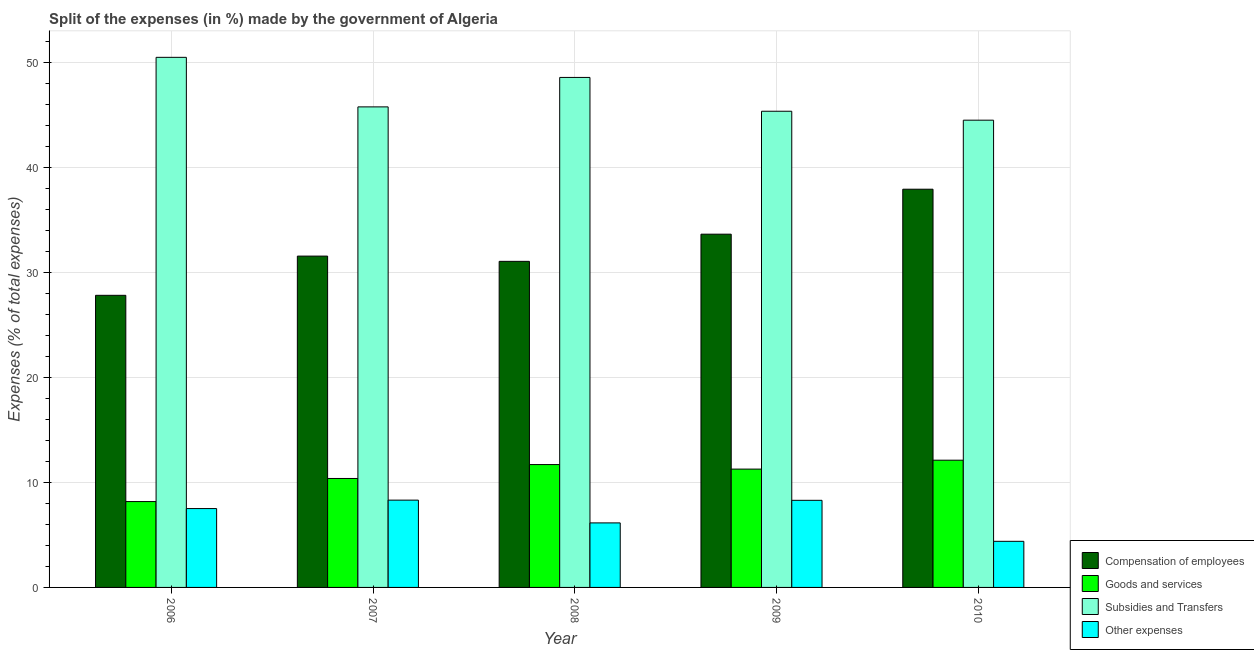How many different coloured bars are there?
Offer a terse response. 4. Are the number of bars per tick equal to the number of legend labels?
Your answer should be very brief. Yes. Are the number of bars on each tick of the X-axis equal?
Offer a terse response. Yes. How many bars are there on the 5th tick from the left?
Offer a terse response. 4. What is the percentage of amount spent on subsidies in 2009?
Offer a terse response. 45.37. Across all years, what is the maximum percentage of amount spent on goods and services?
Provide a succinct answer. 12.12. Across all years, what is the minimum percentage of amount spent on goods and services?
Make the answer very short. 8.18. In which year was the percentage of amount spent on subsidies maximum?
Provide a short and direct response. 2006. What is the total percentage of amount spent on compensation of employees in the graph?
Your response must be concise. 162.06. What is the difference between the percentage of amount spent on other expenses in 2009 and that in 2010?
Make the answer very short. 3.91. What is the difference between the percentage of amount spent on goods and services in 2008 and the percentage of amount spent on subsidies in 2007?
Provide a short and direct response. 1.32. What is the average percentage of amount spent on compensation of employees per year?
Provide a short and direct response. 32.41. In the year 2009, what is the difference between the percentage of amount spent on goods and services and percentage of amount spent on other expenses?
Offer a terse response. 0. In how many years, is the percentage of amount spent on compensation of employees greater than 22 %?
Give a very brief answer. 5. What is the ratio of the percentage of amount spent on subsidies in 2007 to that in 2009?
Give a very brief answer. 1.01. Is the percentage of amount spent on goods and services in 2009 less than that in 2010?
Provide a short and direct response. Yes. Is the difference between the percentage of amount spent on compensation of employees in 2009 and 2010 greater than the difference between the percentage of amount spent on other expenses in 2009 and 2010?
Offer a terse response. No. What is the difference between the highest and the second highest percentage of amount spent on subsidies?
Keep it short and to the point. 1.91. What is the difference between the highest and the lowest percentage of amount spent on goods and services?
Your answer should be compact. 3.94. What does the 2nd bar from the left in 2010 represents?
Your answer should be very brief. Goods and services. What does the 3rd bar from the right in 2006 represents?
Your response must be concise. Goods and services. Is it the case that in every year, the sum of the percentage of amount spent on compensation of employees and percentage of amount spent on goods and services is greater than the percentage of amount spent on subsidies?
Offer a very short reply. No. Are all the bars in the graph horizontal?
Provide a short and direct response. No. How many years are there in the graph?
Provide a succinct answer. 5. Does the graph contain grids?
Keep it short and to the point. Yes. How many legend labels are there?
Ensure brevity in your answer.  4. What is the title of the graph?
Make the answer very short. Split of the expenses (in %) made by the government of Algeria. What is the label or title of the X-axis?
Make the answer very short. Year. What is the label or title of the Y-axis?
Keep it short and to the point. Expenses (% of total expenses). What is the Expenses (% of total expenses) in Compensation of employees in 2006?
Offer a very short reply. 27.83. What is the Expenses (% of total expenses) of Goods and services in 2006?
Provide a short and direct response. 8.18. What is the Expenses (% of total expenses) of Subsidies and Transfers in 2006?
Provide a succinct answer. 50.5. What is the Expenses (% of total expenses) of Other expenses in 2006?
Offer a very short reply. 7.51. What is the Expenses (% of total expenses) in Compensation of employees in 2007?
Provide a short and direct response. 31.57. What is the Expenses (% of total expenses) in Goods and services in 2007?
Ensure brevity in your answer.  10.38. What is the Expenses (% of total expenses) in Subsidies and Transfers in 2007?
Ensure brevity in your answer.  45.78. What is the Expenses (% of total expenses) of Other expenses in 2007?
Offer a terse response. 8.32. What is the Expenses (% of total expenses) in Compensation of employees in 2008?
Your response must be concise. 31.07. What is the Expenses (% of total expenses) of Goods and services in 2008?
Offer a very short reply. 11.7. What is the Expenses (% of total expenses) in Subsidies and Transfers in 2008?
Your response must be concise. 48.59. What is the Expenses (% of total expenses) of Other expenses in 2008?
Offer a terse response. 6.15. What is the Expenses (% of total expenses) in Compensation of employees in 2009?
Provide a succinct answer. 33.66. What is the Expenses (% of total expenses) of Goods and services in 2009?
Make the answer very short. 11.27. What is the Expenses (% of total expenses) of Subsidies and Transfers in 2009?
Provide a short and direct response. 45.37. What is the Expenses (% of total expenses) of Other expenses in 2009?
Keep it short and to the point. 8.3. What is the Expenses (% of total expenses) of Compensation of employees in 2010?
Offer a very short reply. 37.94. What is the Expenses (% of total expenses) in Goods and services in 2010?
Make the answer very short. 12.12. What is the Expenses (% of total expenses) of Subsidies and Transfers in 2010?
Make the answer very short. 44.52. What is the Expenses (% of total expenses) of Other expenses in 2010?
Your answer should be very brief. 4.39. Across all years, what is the maximum Expenses (% of total expenses) of Compensation of employees?
Make the answer very short. 37.94. Across all years, what is the maximum Expenses (% of total expenses) of Goods and services?
Provide a short and direct response. 12.12. Across all years, what is the maximum Expenses (% of total expenses) in Subsidies and Transfers?
Offer a terse response. 50.5. Across all years, what is the maximum Expenses (% of total expenses) in Other expenses?
Ensure brevity in your answer.  8.32. Across all years, what is the minimum Expenses (% of total expenses) of Compensation of employees?
Ensure brevity in your answer.  27.83. Across all years, what is the minimum Expenses (% of total expenses) in Goods and services?
Ensure brevity in your answer.  8.18. Across all years, what is the minimum Expenses (% of total expenses) of Subsidies and Transfers?
Make the answer very short. 44.52. Across all years, what is the minimum Expenses (% of total expenses) of Other expenses?
Offer a terse response. 4.39. What is the total Expenses (% of total expenses) of Compensation of employees in the graph?
Give a very brief answer. 162.06. What is the total Expenses (% of total expenses) of Goods and services in the graph?
Your answer should be very brief. 53.66. What is the total Expenses (% of total expenses) of Subsidies and Transfers in the graph?
Ensure brevity in your answer.  234.76. What is the total Expenses (% of total expenses) of Other expenses in the graph?
Your response must be concise. 34.67. What is the difference between the Expenses (% of total expenses) of Compensation of employees in 2006 and that in 2007?
Provide a succinct answer. -3.74. What is the difference between the Expenses (% of total expenses) of Goods and services in 2006 and that in 2007?
Keep it short and to the point. -2.2. What is the difference between the Expenses (% of total expenses) in Subsidies and Transfers in 2006 and that in 2007?
Make the answer very short. 4.72. What is the difference between the Expenses (% of total expenses) of Other expenses in 2006 and that in 2007?
Your answer should be very brief. -0.8. What is the difference between the Expenses (% of total expenses) of Compensation of employees in 2006 and that in 2008?
Make the answer very short. -3.24. What is the difference between the Expenses (% of total expenses) of Goods and services in 2006 and that in 2008?
Your response must be concise. -3.52. What is the difference between the Expenses (% of total expenses) of Subsidies and Transfers in 2006 and that in 2008?
Your answer should be very brief. 1.91. What is the difference between the Expenses (% of total expenses) in Other expenses in 2006 and that in 2008?
Make the answer very short. 1.36. What is the difference between the Expenses (% of total expenses) in Compensation of employees in 2006 and that in 2009?
Keep it short and to the point. -5.83. What is the difference between the Expenses (% of total expenses) in Goods and services in 2006 and that in 2009?
Offer a very short reply. -3.09. What is the difference between the Expenses (% of total expenses) in Subsidies and Transfers in 2006 and that in 2009?
Offer a very short reply. 5.14. What is the difference between the Expenses (% of total expenses) of Other expenses in 2006 and that in 2009?
Your answer should be very brief. -0.79. What is the difference between the Expenses (% of total expenses) in Compensation of employees in 2006 and that in 2010?
Give a very brief answer. -10.11. What is the difference between the Expenses (% of total expenses) of Goods and services in 2006 and that in 2010?
Your answer should be very brief. -3.94. What is the difference between the Expenses (% of total expenses) of Subsidies and Transfers in 2006 and that in 2010?
Your answer should be compact. 5.99. What is the difference between the Expenses (% of total expenses) of Other expenses in 2006 and that in 2010?
Provide a short and direct response. 3.12. What is the difference between the Expenses (% of total expenses) of Compensation of employees in 2007 and that in 2008?
Give a very brief answer. 0.5. What is the difference between the Expenses (% of total expenses) in Goods and services in 2007 and that in 2008?
Provide a succinct answer. -1.32. What is the difference between the Expenses (% of total expenses) in Subsidies and Transfers in 2007 and that in 2008?
Your response must be concise. -2.81. What is the difference between the Expenses (% of total expenses) in Other expenses in 2007 and that in 2008?
Give a very brief answer. 2.17. What is the difference between the Expenses (% of total expenses) in Compensation of employees in 2007 and that in 2009?
Provide a short and direct response. -2.09. What is the difference between the Expenses (% of total expenses) in Goods and services in 2007 and that in 2009?
Provide a short and direct response. -0.89. What is the difference between the Expenses (% of total expenses) in Subsidies and Transfers in 2007 and that in 2009?
Make the answer very short. 0.42. What is the difference between the Expenses (% of total expenses) of Other expenses in 2007 and that in 2009?
Keep it short and to the point. 0.02. What is the difference between the Expenses (% of total expenses) of Compensation of employees in 2007 and that in 2010?
Ensure brevity in your answer.  -6.37. What is the difference between the Expenses (% of total expenses) of Goods and services in 2007 and that in 2010?
Provide a short and direct response. -1.74. What is the difference between the Expenses (% of total expenses) of Subsidies and Transfers in 2007 and that in 2010?
Provide a short and direct response. 1.27. What is the difference between the Expenses (% of total expenses) in Other expenses in 2007 and that in 2010?
Your response must be concise. 3.92. What is the difference between the Expenses (% of total expenses) of Compensation of employees in 2008 and that in 2009?
Your answer should be very brief. -2.59. What is the difference between the Expenses (% of total expenses) of Goods and services in 2008 and that in 2009?
Provide a succinct answer. 0.43. What is the difference between the Expenses (% of total expenses) in Subsidies and Transfers in 2008 and that in 2009?
Your answer should be compact. 3.22. What is the difference between the Expenses (% of total expenses) in Other expenses in 2008 and that in 2009?
Offer a very short reply. -2.15. What is the difference between the Expenses (% of total expenses) in Compensation of employees in 2008 and that in 2010?
Offer a terse response. -6.87. What is the difference between the Expenses (% of total expenses) in Goods and services in 2008 and that in 2010?
Give a very brief answer. -0.42. What is the difference between the Expenses (% of total expenses) in Subsidies and Transfers in 2008 and that in 2010?
Keep it short and to the point. 4.07. What is the difference between the Expenses (% of total expenses) of Other expenses in 2008 and that in 2010?
Provide a short and direct response. 1.75. What is the difference between the Expenses (% of total expenses) of Compensation of employees in 2009 and that in 2010?
Give a very brief answer. -4.28. What is the difference between the Expenses (% of total expenses) in Goods and services in 2009 and that in 2010?
Keep it short and to the point. -0.85. What is the difference between the Expenses (% of total expenses) in Subsidies and Transfers in 2009 and that in 2010?
Offer a terse response. 0.85. What is the difference between the Expenses (% of total expenses) of Other expenses in 2009 and that in 2010?
Make the answer very short. 3.91. What is the difference between the Expenses (% of total expenses) of Compensation of employees in 2006 and the Expenses (% of total expenses) of Goods and services in 2007?
Your response must be concise. 17.45. What is the difference between the Expenses (% of total expenses) in Compensation of employees in 2006 and the Expenses (% of total expenses) in Subsidies and Transfers in 2007?
Your answer should be very brief. -17.95. What is the difference between the Expenses (% of total expenses) of Compensation of employees in 2006 and the Expenses (% of total expenses) of Other expenses in 2007?
Provide a succinct answer. 19.51. What is the difference between the Expenses (% of total expenses) in Goods and services in 2006 and the Expenses (% of total expenses) in Subsidies and Transfers in 2007?
Your response must be concise. -37.6. What is the difference between the Expenses (% of total expenses) in Goods and services in 2006 and the Expenses (% of total expenses) in Other expenses in 2007?
Ensure brevity in your answer.  -0.14. What is the difference between the Expenses (% of total expenses) of Subsidies and Transfers in 2006 and the Expenses (% of total expenses) of Other expenses in 2007?
Make the answer very short. 42.19. What is the difference between the Expenses (% of total expenses) of Compensation of employees in 2006 and the Expenses (% of total expenses) of Goods and services in 2008?
Your response must be concise. 16.13. What is the difference between the Expenses (% of total expenses) in Compensation of employees in 2006 and the Expenses (% of total expenses) in Subsidies and Transfers in 2008?
Provide a short and direct response. -20.76. What is the difference between the Expenses (% of total expenses) in Compensation of employees in 2006 and the Expenses (% of total expenses) in Other expenses in 2008?
Provide a succinct answer. 21.68. What is the difference between the Expenses (% of total expenses) of Goods and services in 2006 and the Expenses (% of total expenses) of Subsidies and Transfers in 2008?
Your answer should be compact. -40.41. What is the difference between the Expenses (% of total expenses) in Goods and services in 2006 and the Expenses (% of total expenses) in Other expenses in 2008?
Provide a succinct answer. 2.03. What is the difference between the Expenses (% of total expenses) of Subsidies and Transfers in 2006 and the Expenses (% of total expenses) of Other expenses in 2008?
Keep it short and to the point. 44.36. What is the difference between the Expenses (% of total expenses) in Compensation of employees in 2006 and the Expenses (% of total expenses) in Goods and services in 2009?
Offer a very short reply. 16.56. What is the difference between the Expenses (% of total expenses) in Compensation of employees in 2006 and the Expenses (% of total expenses) in Subsidies and Transfers in 2009?
Your answer should be compact. -17.54. What is the difference between the Expenses (% of total expenses) in Compensation of employees in 2006 and the Expenses (% of total expenses) in Other expenses in 2009?
Your response must be concise. 19.53. What is the difference between the Expenses (% of total expenses) of Goods and services in 2006 and the Expenses (% of total expenses) of Subsidies and Transfers in 2009?
Offer a very short reply. -37.19. What is the difference between the Expenses (% of total expenses) of Goods and services in 2006 and the Expenses (% of total expenses) of Other expenses in 2009?
Ensure brevity in your answer.  -0.12. What is the difference between the Expenses (% of total expenses) of Subsidies and Transfers in 2006 and the Expenses (% of total expenses) of Other expenses in 2009?
Your answer should be compact. 42.21. What is the difference between the Expenses (% of total expenses) in Compensation of employees in 2006 and the Expenses (% of total expenses) in Goods and services in 2010?
Your answer should be compact. 15.71. What is the difference between the Expenses (% of total expenses) in Compensation of employees in 2006 and the Expenses (% of total expenses) in Subsidies and Transfers in 2010?
Make the answer very short. -16.69. What is the difference between the Expenses (% of total expenses) in Compensation of employees in 2006 and the Expenses (% of total expenses) in Other expenses in 2010?
Your answer should be very brief. 23.44. What is the difference between the Expenses (% of total expenses) of Goods and services in 2006 and the Expenses (% of total expenses) of Subsidies and Transfers in 2010?
Your response must be concise. -36.34. What is the difference between the Expenses (% of total expenses) of Goods and services in 2006 and the Expenses (% of total expenses) of Other expenses in 2010?
Ensure brevity in your answer.  3.79. What is the difference between the Expenses (% of total expenses) of Subsidies and Transfers in 2006 and the Expenses (% of total expenses) of Other expenses in 2010?
Offer a very short reply. 46.11. What is the difference between the Expenses (% of total expenses) of Compensation of employees in 2007 and the Expenses (% of total expenses) of Goods and services in 2008?
Your answer should be very brief. 19.86. What is the difference between the Expenses (% of total expenses) in Compensation of employees in 2007 and the Expenses (% of total expenses) in Subsidies and Transfers in 2008?
Give a very brief answer. -17.02. What is the difference between the Expenses (% of total expenses) in Compensation of employees in 2007 and the Expenses (% of total expenses) in Other expenses in 2008?
Keep it short and to the point. 25.42. What is the difference between the Expenses (% of total expenses) in Goods and services in 2007 and the Expenses (% of total expenses) in Subsidies and Transfers in 2008?
Provide a succinct answer. -38.21. What is the difference between the Expenses (% of total expenses) in Goods and services in 2007 and the Expenses (% of total expenses) in Other expenses in 2008?
Make the answer very short. 4.23. What is the difference between the Expenses (% of total expenses) in Subsidies and Transfers in 2007 and the Expenses (% of total expenses) in Other expenses in 2008?
Give a very brief answer. 39.64. What is the difference between the Expenses (% of total expenses) of Compensation of employees in 2007 and the Expenses (% of total expenses) of Goods and services in 2009?
Give a very brief answer. 20.29. What is the difference between the Expenses (% of total expenses) of Compensation of employees in 2007 and the Expenses (% of total expenses) of Subsidies and Transfers in 2009?
Provide a short and direct response. -13.8. What is the difference between the Expenses (% of total expenses) of Compensation of employees in 2007 and the Expenses (% of total expenses) of Other expenses in 2009?
Give a very brief answer. 23.27. What is the difference between the Expenses (% of total expenses) in Goods and services in 2007 and the Expenses (% of total expenses) in Subsidies and Transfers in 2009?
Keep it short and to the point. -34.99. What is the difference between the Expenses (% of total expenses) in Goods and services in 2007 and the Expenses (% of total expenses) in Other expenses in 2009?
Your answer should be very brief. 2.08. What is the difference between the Expenses (% of total expenses) of Subsidies and Transfers in 2007 and the Expenses (% of total expenses) of Other expenses in 2009?
Provide a succinct answer. 37.48. What is the difference between the Expenses (% of total expenses) of Compensation of employees in 2007 and the Expenses (% of total expenses) of Goods and services in 2010?
Offer a very short reply. 19.45. What is the difference between the Expenses (% of total expenses) in Compensation of employees in 2007 and the Expenses (% of total expenses) in Subsidies and Transfers in 2010?
Your answer should be compact. -12.95. What is the difference between the Expenses (% of total expenses) of Compensation of employees in 2007 and the Expenses (% of total expenses) of Other expenses in 2010?
Offer a terse response. 27.17. What is the difference between the Expenses (% of total expenses) in Goods and services in 2007 and the Expenses (% of total expenses) in Subsidies and Transfers in 2010?
Give a very brief answer. -34.14. What is the difference between the Expenses (% of total expenses) of Goods and services in 2007 and the Expenses (% of total expenses) of Other expenses in 2010?
Make the answer very short. 5.99. What is the difference between the Expenses (% of total expenses) in Subsidies and Transfers in 2007 and the Expenses (% of total expenses) in Other expenses in 2010?
Provide a short and direct response. 41.39. What is the difference between the Expenses (% of total expenses) of Compensation of employees in 2008 and the Expenses (% of total expenses) of Goods and services in 2009?
Your answer should be compact. 19.79. What is the difference between the Expenses (% of total expenses) in Compensation of employees in 2008 and the Expenses (% of total expenses) in Subsidies and Transfers in 2009?
Ensure brevity in your answer.  -14.3. What is the difference between the Expenses (% of total expenses) in Compensation of employees in 2008 and the Expenses (% of total expenses) in Other expenses in 2009?
Give a very brief answer. 22.77. What is the difference between the Expenses (% of total expenses) in Goods and services in 2008 and the Expenses (% of total expenses) in Subsidies and Transfers in 2009?
Offer a terse response. -33.66. What is the difference between the Expenses (% of total expenses) in Goods and services in 2008 and the Expenses (% of total expenses) in Other expenses in 2009?
Make the answer very short. 3.41. What is the difference between the Expenses (% of total expenses) of Subsidies and Transfers in 2008 and the Expenses (% of total expenses) of Other expenses in 2009?
Give a very brief answer. 40.29. What is the difference between the Expenses (% of total expenses) in Compensation of employees in 2008 and the Expenses (% of total expenses) in Goods and services in 2010?
Your response must be concise. 18.95. What is the difference between the Expenses (% of total expenses) of Compensation of employees in 2008 and the Expenses (% of total expenses) of Subsidies and Transfers in 2010?
Your answer should be very brief. -13.45. What is the difference between the Expenses (% of total expenses) of Compensation of employees in 2008 and the Expenses (% of total expenses) of Other expenses in 2010?
Offer a terse response. 26.67. What is the difference between the Expenses (% of total expenses) in Goods and services in 2008 and the Expenses (% of total expenses) in Subsidies and Transfers in 2010?
Offer a very short reply. -32.81. What is the difference between the Expenses (% of total expenses) of Goods and services in 2008 and the Expenses (% of total expenses) of Other expenses in 2010?
Offer a terse response. 7.31. What is the difference between the Expenses (% of total expenses) in Subsidies and Transfers in 2008 and the Expenses (% of total expenses) in Other expenses in 2010?
Offer a terse response. 44.2. What is the difference between the Expenses (% of total expenses) in Compensation of employees in 2009 and the Expenses (% of total expenses) in Goods and services in 2010?
Provide a succinct answer. 21.53. What is the difference between the Expenses (% of total expenses) of Compensation of employees in 2009 and the Expenses (% of total expenses) of Subsidies and Transfers in 2010?
Keep it short and to the point. -10.86. What is the difference between the Expenses (% of total expenses) in Compensation of employees in 2009 and the Expenses (% of total expenses) in Other expenses in 2010?
Your answer should be compact. 29.26. What is the difference between the Expenses (% of total expenses) in Goods and services in 2009 and the Expenses (% of total expenses) in Subsidies and Transfers in 2010?
Keep it short and to the point. -33.24. What is the difference between the Expenses (% of total expenses) of Goods and services in 2009 and the Expenses (% of total expenses) of Other expenses in 2010?
Give a very brief answer. 6.88. What is the difference between the Expenses (% of total expenses) of Subsidies and Transfers in 2009 and the Expenses (% of total expenses) of Other expenses in 2010?
Give a very brief answer. 40.97. What is the average Expenses (% of total expenses) of Compensation of employees per year?
Offer a terse response. 32.41. What is the average Expenses (% of total expenses) of Goods and services per year?
Provide a succinct answer. 10.73. What is the average Expenses (% of total expenses) in Subsidies and Transfers per year?
Provide a short and direct response. 46.95. What is the average Expenses (% of total expenses) in Other expenses per year?
Offer a terse response. 6.93. In the year 2006, what is the difference between the Expenses (% of total expenses) of Compensation of employees and Expenses (% of total expenses) of Goods and services?
Your response must be concise. 19.65. In the year 2006, what is the difference between the Expenses (% of total expenses) in Compensation of employees and Expenses (% of total expenses) in Subsidies and Transfers?
Your answer should be very brief. -22.67. In the year 2006, what is the difference between the Expenses (% of total expenses) of Compensation of employees and Expenses (% of total expenses) of Other expenses?
Your response must be concise. 20.32. In the year 2006, what is the difference between the Expenses (% of total expenses) in Goods and services and Expenses (% of total expenses) in Subsidies and Transfers?
Give a very brief answer. -42.32. In the year 2006, what is the difference between the Expenses (% of total expenses) in Goods and services and Expenses (% of total expenses) in Other expenses?
Your answer should be very brief. 0.67. In the year 2006, what is the difference between the Expenses (% of total expenses) of Subsidies and Transfers and Expenses (% of total expenses) of Other expenses?
Offer a terse response. 42.99. In the year 2007, what is the difference between the Expenses (% of total expenses) of Compensation of employees and Expenses (% of total expenses) of Goods and services?
Offer a terse response. 21.19. In the year 2007, what is the difference between the Expenses (% of total expenses) of Compensation of employees and Expenses (% of total expenses) of Subsidies and Transfers?
Give a very brief answer. -14.22. In the year 2007, what is the difference between the Expenses (% of total expenses) of Compensation of employees and Expenses (% of total expenses) of Other expenses?
Offer a very short reply. 23.25. In the year 2007, what is the difference between the Expenses (% of total expenses) in Goods and services and Expenses (% of total expenses) in Subsidies and Transfers?
Make the answer very short. -35.4. In the year 2007, what is the difference between the Expenses (% of total expenses) in Goods and services and Expenses (% of total expenses) in Other expenses?
Offer a terse response. 2.06. In the year 2007, what is the difference between the Expenses (% of total expenses) of Subsidies and Transfers and Expenses (% of total expenses) of Other expenses?
Give a very brief answer. 37.47. In the year 2008, what is the difference between the Expenses (% of total expenses) in Compensation of employees and Expenses (% of total expenses) in Goods and services?
Provide a short and direct response. 19.36. In the year 2008, what is the difference between the Expenses (% of total expenses) of Compensation of employees and Expenses (% of total expenses) of Subsidies and Transfers?
Give a very brief answer. -17.52. In the year 2008, what is the difference between the Expenses (% of total expenses) of Compensation of employees and Expenses (% of total expenses) of Other expenses?
Provide a short and direct response. 24.92. In the year 2008, what is the difference between the Expenses (% of total expenses) of Goods and services and Expenses (% of total expenses) of Subsidies and Transfers?
Your answer should be compact. -36.89. In the year 2008, what is the difference between the Expenses (% of total expenses) in Goods and services and Expenses (% of total expenses) in Other expenses?
Make the answer very short. 5.56. In the year 2008, what is the difference between the Expenses (% of total expenses) in Subsidies and Transfers and Expenses (% of total expenses) in Other expenses?
Give a very brief answer. 42.44. In the year 2009, what is the difference between the Expenses (% of total expenses) in Compensation of employees and Expenses (% of total expenses) in Goods and services?
Your answer should be compact. 22.38. In the year 2009, what is the difference between the Expenses (% of total expenses) in Compensation of employees and Expenses (% of total expenses) in Subsidies and Transfers?
Keep it short and to the point. -11.71. In the year 2009, what is the difference between the Expenses (% of total expenses) of Compensation of employees and Expenses (% of total expenses) of Other expenses?
Your response must be concise. 25.36. In the year 2009, what is the difference between the Expenses (% of total expenses) in Goods and services and Expenses (% of total expenses) in Subsidies and Transfers?
Offer a very short reply. -34.09. In the year 2009, what is the difference between the Expenses (% of total expenses) in Goods and services and Expenses (% of total expenses) in Other expenses?
Offer a terse response. 2.97. In the year 2009, what is the difference between the Expenses (% of total expenses) in Subsidies and Transfers and Expenses (% of total expenses) in Other expenses?
Give a very brief answer. 37.07. In the year 2010, what is the difference between the Expenses (% of total expenses) in Compensation of employees and Expenses (% of total expenses) in Goods and services?
Your answer should be very brief. 25.82. In the year 2010, what is the difference between the Expenses (% of total expenses) in Compensation of employees and Expenses (% of total expenses) in Subsidies and Transfers?
Your answer should be very brief. -6.58. In the year 2010, what is the difference between the Expenses (% of total expenses) in Compensation of employees and Expenses (% of total expenses) in Other expenses?
Give a very brief answer. 33.55. In the year 2010, what is the difference between the Expenses (% of total expenses) of Goods and services and Expenses (% of total expenses) of Subsidies and Transfers?
Offer a terse response. -32.4. In the year 2010, what is the difference between the Expenses (% of total expenses) of Goods and services and Expenses (% of total expenses) of Other expenses?
Your answer should be compact. 7.73. In the year 2010, what is the difference between the Expenses (% of total expenses) in Subsidies and Transfers and Expenses (% of total expenses) in Other expenses?
Provide a succinct answer. 40.12. What is the ratio of the Expenses (% of total expenses) in Compensation of employees in 2006 to that in 2007?
Offer a very short reply. 0.88. What is the ratio of the Expenses (% of total expenses) of Goods and services in 2006 to that in 2007?
Your answer should be compact. 0.79. What is the ratio of the Expenses (% of total expenses) in Subsidies and Transfers in 2006 to that in 2007?
Provide a succinct answer. 1.1. What is the ratio of the Expenses (% of total expenses) in Other expenses in 2006 to that in 2007?
Offer a very short reply. 0.9. What is the ratio of the Expenses (% of total expenses) of Compensation of employees in 2006 to that in 2008?
Keep it short and to the point. 0.9. What is the ratio of the Expenses (% of total expenses) of Goods and services in 2006 to that in 2008?
Offer a very short reply. 0.7. What is the ratio of the Expenses (% of total expenses) in Subsidies and Transfers in 2006 to that in 2008?
Give a very brief answer. 1.04. What is the ratio of the Expenses (% of total expenses) of Other expenses in 2006 to that in 2008?
Your response must be concise. 1.22. What is the ratio of the Expenses (% of total expenses) in Compensation of employees in 2006 to that in 2009?
Offer a very short reply. 0.83. What is the ratio of the Expenses (% of total expenses) of Goods and services in 2006 to that in 2009?
Your answer should be very brief. 0.73. What is the ratio of the Expenses (% of total expenses) in Subsidies and Transfers in 2006 to that in 2009?
Make the answer very short. 1.11. What is the ratio of the Expenses (% of total expenses) of Other expenses in 2006 to that in 2009?
Your answer should be very brief. 0.91. What is the ratio of the Expenses (% of total expenses) in Compensation of employees in 2006 to that in 2010?
Give a very brief answer. 0.73. What is the ratio of the Expenses (% of total expenses) in Goods and services in 2006 to that in 2010?
Give a very brief answer. 0.67. What is the ratio of the Expenses (% of total expenses) in Subsidies and Transfers in 2006 to that in 2010?
Offer a very short reply. 1.13. What is the ratio of the Expenses (% of total expenses) in Other expenses in 2006 to that in 2010?
Your answer should be very brief. 1.71. What is the ratio of the Expenses (% of total expenses) of Compensation of employees in 2007 to that in 2008?
Make the answer very short. 1.02. What is the ratio of the Expenses (% of total expenses) in Goods and services in 2007 to that in 2008?
Your answer should be compact. 0.89. What is the ratio of the Expenses (% of total expenses) in Subsidies and Transfers in 2007 to that in 2008?
Your response must be concise. 0.94. What is the ratio of the Expenses (% of total expenses) in Other expenses in 2007 to that in 2008?
Keep it short and to the point. 1.35. What is the ratio of the Expenses (% of total expenses) in Compensation of employees in 2007 to that in 2009?
Provide a succinct answer. 0.94. What is the ratio of the Expenses (% of total expenses) in Goods and services in 2007 to that in 2009?
Give a very brief answer. 0.92. What is the ratio of the Expenses (% of total expenses) of Subsidies and Transfers in 2007 to that in 2009?
Offer a very short reply. 1.01. What is the ratio of the Expenses (% of total expenses) of Compensation of employees in 2007 to that in 2010?
Keep it short and to the point. 0.83. What is the ratio of the Expenses (% of total expenses) of Goods and services in 2007 to that in 2010?
Your answer should be very brief. 0.86. What is the ratio of the Expenses (% of total expenses) of Subsidies and Transfers in 2007 to that in 2010?
Offer a terse response. 1.03. What is the ratio of the Expenses (% of total expenses) in Other expenses in 2007 to that in 2010?
Make the answer very short. 1.89. What is the ratio of the Expenses (% of total expenses) of Goods and services in 2008 to that in 2009?
Offer a very short reply. 1.04. What is the ratio of the Expenses (% of total expenses) of Subsidies and Transfers in 2008 to that in 2009?
Your answer should be compact. 1.07. What is the ratio of the Expenses (% of total expenses) in Other expenses in 2008 to that in 2009?
Keep it short and to the point. 0.74. What is the ratio of the Expenses (% of total expenses) of Compensation of employees in 2008 to that in 2010?
Your answer should be very brief. 0.82. What is the ratio of the Expenses (% of total expenses) of Goods and services in 2008 to that in 2010?
Your answer should be very brief. 0.97. What is the ratio of the Expenses (% of total expenses) in Subsidies and Transfers in 2008 to that in 2010?
Offer a terse response. 1.09. What is the ratio of the Expenses (% of total expenses) in Other expenses in 2008 to that in 2010?
Keep it short and to the point. 1.4. What is the ratio of the Expenses (% of total expenses) in Compensation of employees in 2009 to that in 2010?
Provide a succinct answer. 0.89. What is the ratio of the Expenses (% of total expenses) in Goods and services in 2009 to that in 2010?
Offer a terse response. 0.93. What is the ratio of the Expenses (% of total expenses) in Subsidies and Transfers in 2009 to that in 2010?
Your response must be concise. 1.02. What is the ratio of the Expenses (% of total expenses) in Other expenses in 2009 to that in 2010?
Offer a very short reply. 1.89. What is the difference between the highest and the second highest Expenses (% of total expenses) of Compensation of employees?
Provide a succinct answer. 4.28. What is the difference between the highest and the second highest Expenses (% of total expenses) in Goods and services?
Provide a short and direct response. 0.42. What is the difference between the highest and the second highest Expenses (% of total expenses) of Subsidies and Transfers?
Ensure brevity in your answer.  1.91. What is the difference between the highest and the second highest Expenses (% of total expenses) of Other expenses?
Offer a very short reply. 0.02. What is the difference between the highest and the lowest Expenses (% of total expenses) in Compensation of employees?
Make the answer very short. 10.11. What is the difference between the highest and the lowest Expenses (% of total expenses) in Goods and services?
Make the answer very short. 3.94. What is the difference between the highest and the lowest Expenses (% of total expenses) of Subsidies and Transfers?
Your answer should be compact. 5.99. What is the difference between the highest and the lowest Expenses (% of total expenses) in Other expenses?
Your answer should be very brief. 3.92. 